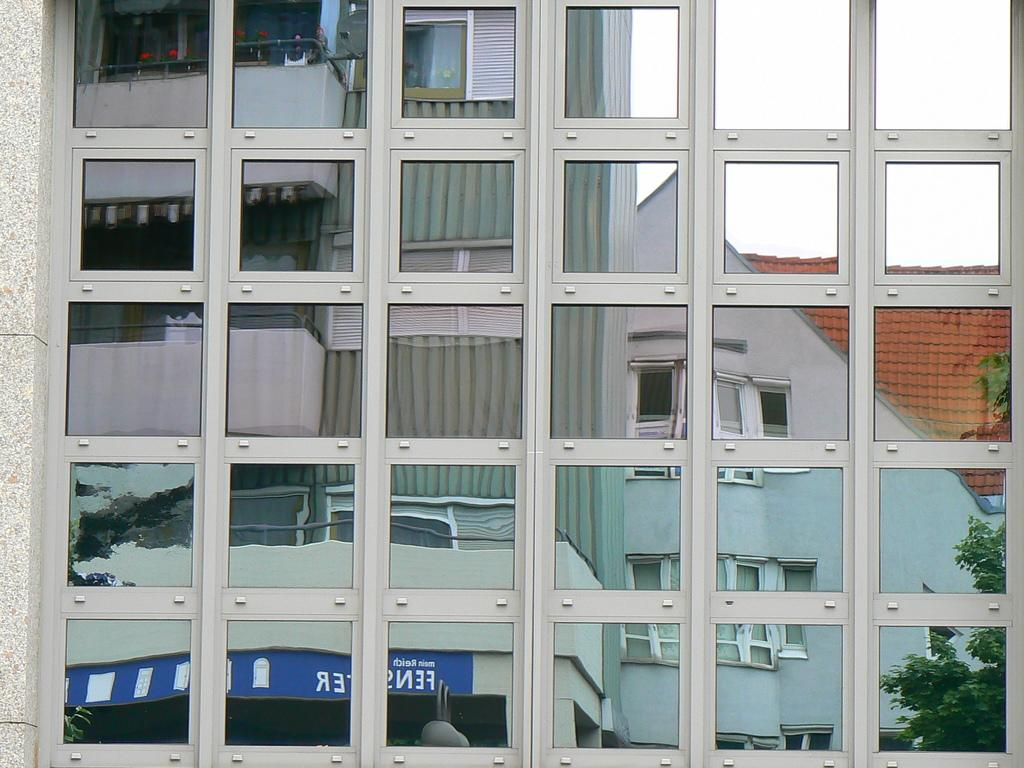What is reflected in the image? There is a reflection of a building in the image. What type of vegetation is present in the image? There is a tree at the right side of the image. What type of drum can be seen in the image? There is no drum present in the image. What emotion is being expressed by the tree in the image? Trees do not express emotions, so this question cannot be answered. 